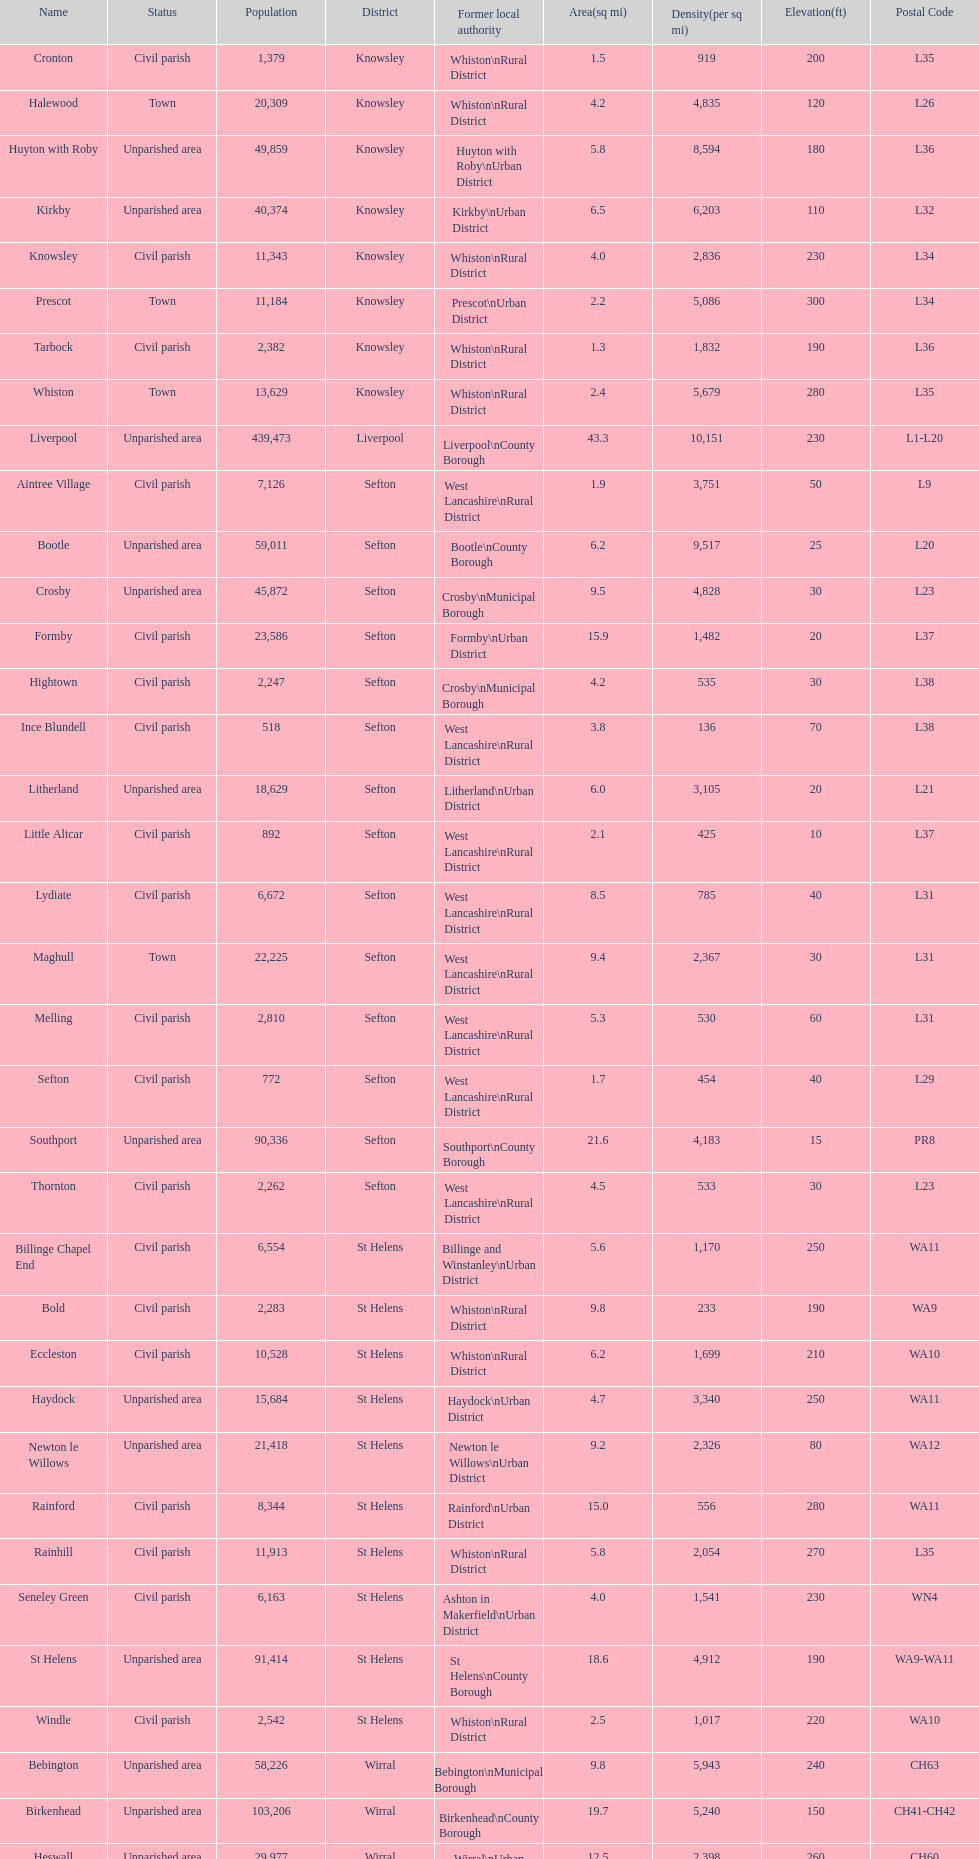How many civil parishes have population counts of at least 10,000? 4. 